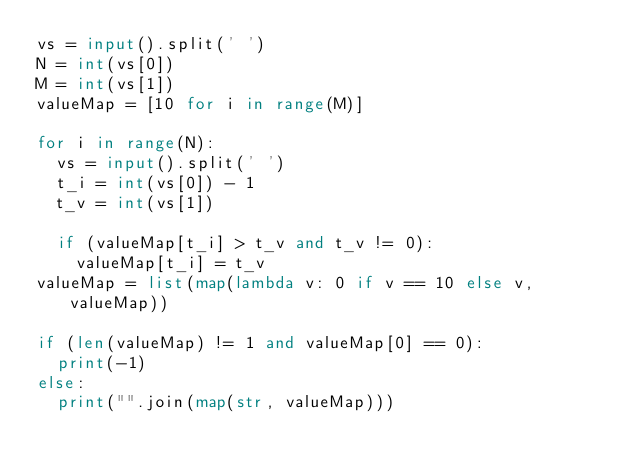Convert code to text. <code><loc_0><loc_0><loc_500><loc_500><_Python_>vs = input().split(' ')
N = int(vs[0])
M = int(vs[1])
valueMap = [10 for i in range(M)]

for i in range(N):
  vs = input().split(' ')
  t_i = int(vs[0]) - 1
  t_v = int(vs[1])

  if (valueMap[t_i] > t_v and t_v != 0):
    valueMap[t_i] = t_v
valueMap = list(map(lambda v: 0 if v == 10 else v, valueMap))

if (len(valueMap) != 1 and valueMap[0] == 0):
  print(-1)
else:
  print("".join(map(str, valueMap)))
</code> 